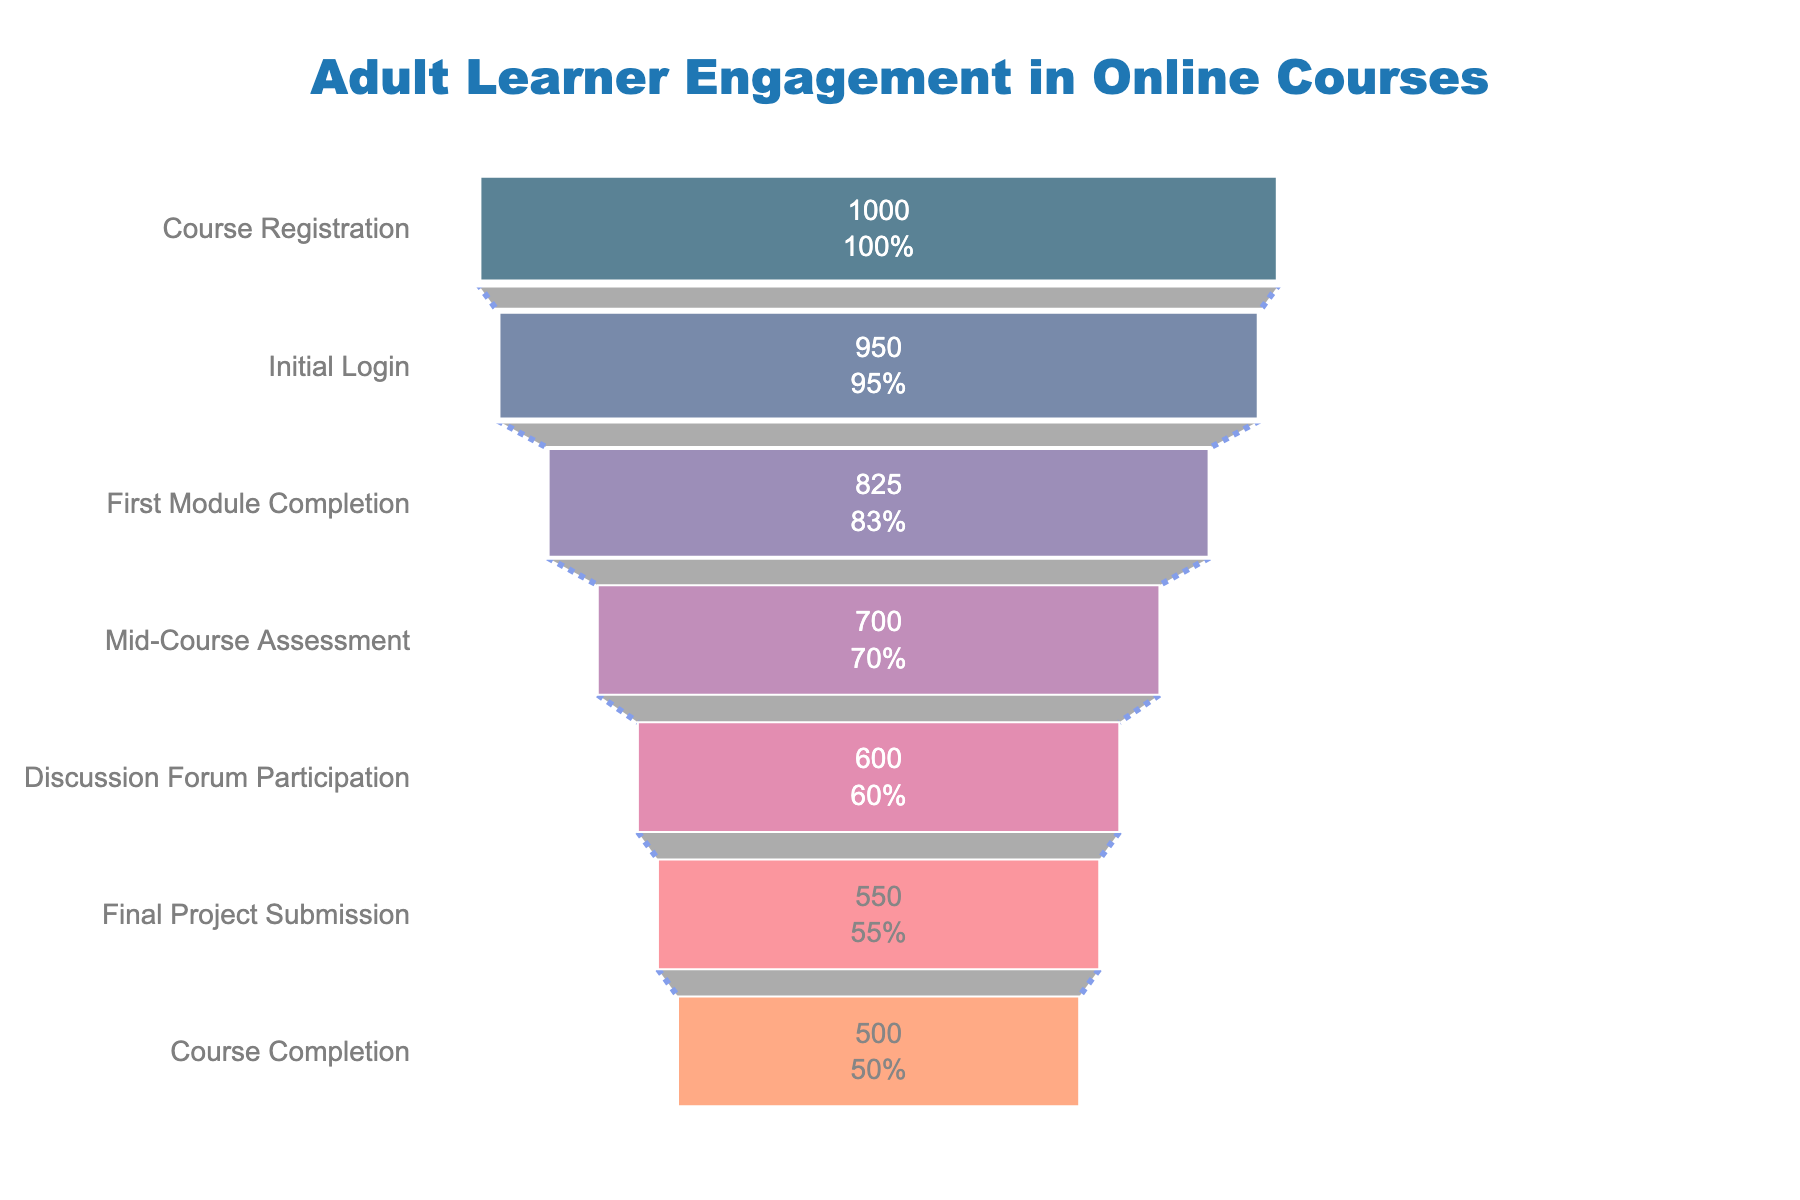What is the title of the figure? Look at the top of the chart where the title is displayed. The title usually summarizes the main focus of the chart.
Answer: Adult Learner Engagement in Online Courses How many stages are represented in the funnel chart? Count the number of distinct stages listed on the y-axis of the funnel chart.
Answer: 7 What is the percentage of learners who completed the course starting from the initial login? Divide the number of learners who completed the course by the number of learners who initially logged in, then multiply by 100 to get the percentage. Calculation: (500 / 950) * 100.
Answer: 52.63% Which stage has the highest drop in learner numbers? Look at the absolute difference in the number of learners between each adjacently listed stage. Identify the pair of stages with the largest decrease.
Answer: Initial Login to First Module Completion How many learners dropped out between the Initial Login and the Final Project Submission? Subtract the number of learners at the Final Project Submission stage from the number of learners at the Initial Login stage. Calculation: 950 - 550.
Answer: 400 What is the difference in learner numbers between the Mid-Course Assessment and Discussion Forum Participation stages? Calculate the absolute difference between the number of learners in the Mid-Course Assessment stage and the Discussion Forum Participation stage. Calculation: 700 - 600.
Answer: 100 What percentage of learners participated in the Discussion Forum compared to those who completed the First Module? Divide the number of learners who participated in the Discussion Forum by the number of learners who completed the First Module, then multiply by 100. Calculation: (600 / 825) * 100.
Answer: 72.73% Which stage represents the smallest percentage drop in the number of learners? Calculate the percentage drop for each stage by comparing the number of learners remaining with the previous stage. Identify the stage with the smallest percentage drop.
Answer: Final Project Submission to Course Completion What is the average number of learners from Initial Login to Course Completion across all stages? Add the number of learners from Initial Login to Course Completion, then divide by the number of stages between these two points (inclusive). Calculation: (950 + 825 + 700 + 600 + 550 + 500) / 6.
Answer: 687.5 